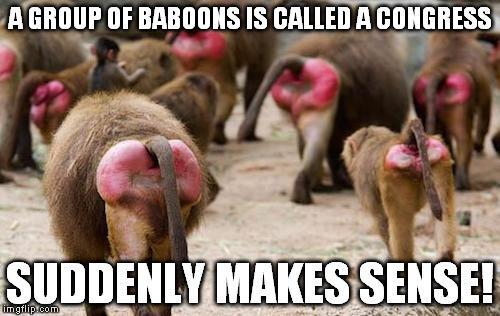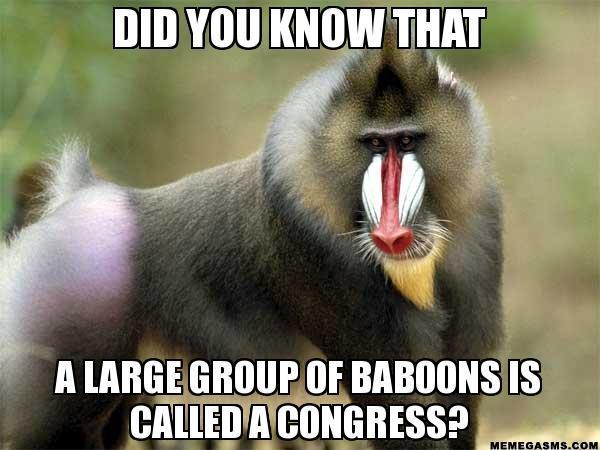The first image is the image on the left, the second image is the image on the right. Considering the images on both sides, is "there are man made objects in the image on the left." valid? Answer yes or no. No. 